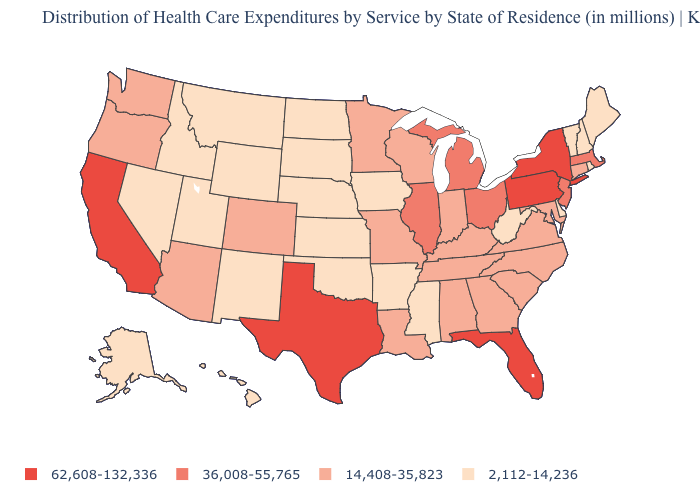Among the states that border Mississippi , which have the lowest value?
Short answer required. Arkansas. Is the legend a continuous bar?
Concise answer only. No. Which states hav the highest value in the South?
Write a very short answer. Florida, Texas. Which states have the highest value in the USA?
Keep it brief. California, Florida, New York, Pennsylvania, Texas. What is the lowest value in the USA?
Write a very short answer. 2,112-14,236. Is the legend a continuous bar?
Give a very brief answer. No. Does Florida have the highest value in the USA?
Quick response, please. Yes. Name the states that have a value in the range 2,112-14,236?
Concise answer only. Alaska, Arkansas, Delaware, Hawaii, Idaho, Iowa, Kansas, Maine, Mississippi, Montana, Nebraska, Nevada, New Hampshire, New Mexico, North Dakota, Oklahoma, Rhode Island, South Dakota, Utah, Vermont, West Virginia, Wyoming. Which states hav the highest value in the MidWest?
Write a very short answer. Illinois, Michigan, Ohio. Which states have the highest value in the USA?
Be succinct. California, Florida, New York, Pennsylvania, Texas. Does New Hampshire have a higher value than Iowa?
Be succinct. No. How many symbols are there in the legend?
Answer briefly. 4. Name the states that have a value in the range 14,408-35,823?
Keep it brief. Alabama, Arizona, Colorado, Connecticut, Georgia, Indiana, Kentucky, Louisiana, Maryland, Minnesota, Missouri, North Carolina, Oregon, South Carolina, Tennessee, Virginia, Washington, Wisconsin. Which states hav the highest value in the South?
Concise answer only. Florida, Texas. Among the states that border New York , which have the highest value?
Keep it brief. Pennsylvania. 